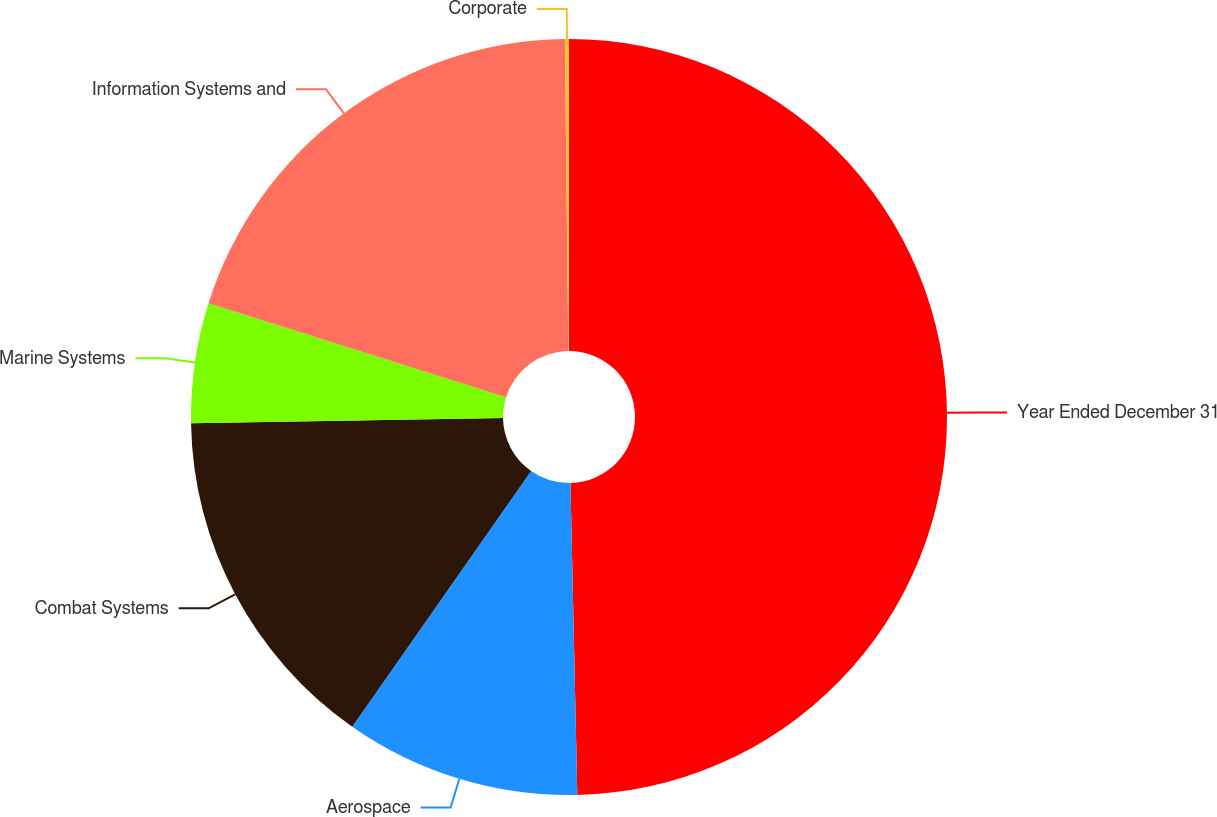<chart> <loc_0><loc_0><loc_500><loc_500><pie_chart><fcel>Year Ended December 31<fcel>Aerospace<fcel>Combat Systems<fcel>Marine Systems<fcel>Information Systems and<fcel>Corporate<nl><fcel>49.65%<fcel>10.07%<fcel>15.02%<fcel>5.12%<fcel>19.97%<fcel>0.17%<nl></chart> 